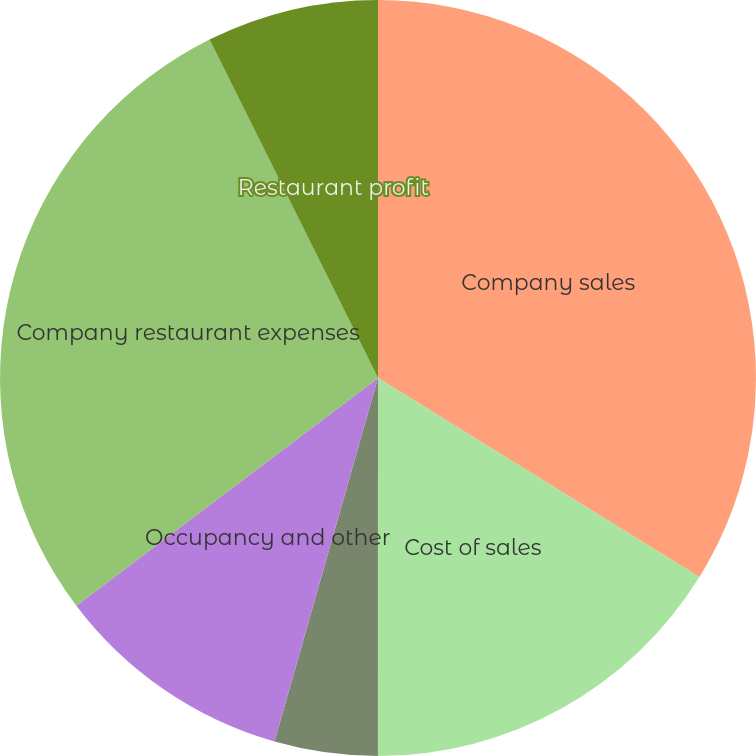Convert chart to OTSL. <chart><loc_0><loc_0><loc_500><loc_500><pie_chart><fcel>Company sales<fcel>Cost of sales<fcel>Cost of labor<fcel>Occupancy and other<fcel>Company restaurant expenses<fcel>Restaurant profit<nl><fcel>33.82%<fcel>16.18%<fcel>4.41%<fcel>10.29%<fcel>27.94%<fcel>7.35%<nl></chart> 